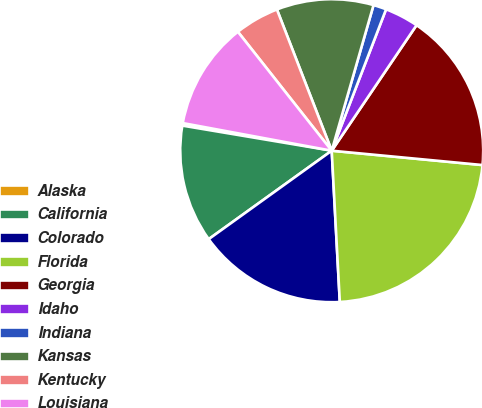Convert chart to OTSL. <chart><loc_0><loc_0><loc_500><loc_500><pie_chart><fcel>Alaska<fcel>California<fcel>Colorado<fcel>Florida<fcel>Georgia<fcel>Idaho<fcel>Indiana<fcel>Kansas<fcel>Kentucky<fcel>Louisiana<nl><fcel>0.27%<fcel>12.57%<fcel>15.93%<fcel>22.64%<fcel>17.05%<fcel>3.62%<fcel>1.39%<fcel>10.34%<fcel>4.74%<fcel>11.45%<nl></chart> 